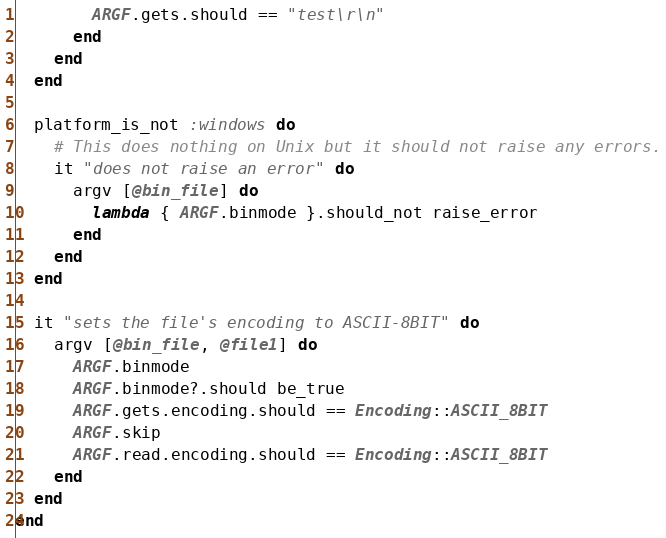Convert code to text. <code><loc_0><loc_0><loc_500><loc_500><_Ruby_>        ARGF.gets.should == "test\r\n"
      end
    end
  end

  platform_is_not :windows do
    # This does nothing on Unix but it should not raise any errors.
    it "does not raise an error" do
      argv [@bin_file] do
        lambda { ARGF.binmode }.should_not raise_error
      end
    end
  end

  it "sets the file's encoding to ASCII-8BIT" do
    argv [@bin_file, @file1] do
      ARGF.binmode
      ARGF.binmode?.should be_true
      ARGF.gets.encoding.should == Encoding::ASCII_8BIT
      ARGF.skip
      ARGF.read.encoding.should == Encoding::ASCII_8BIT
    end
  end
end
</code> 